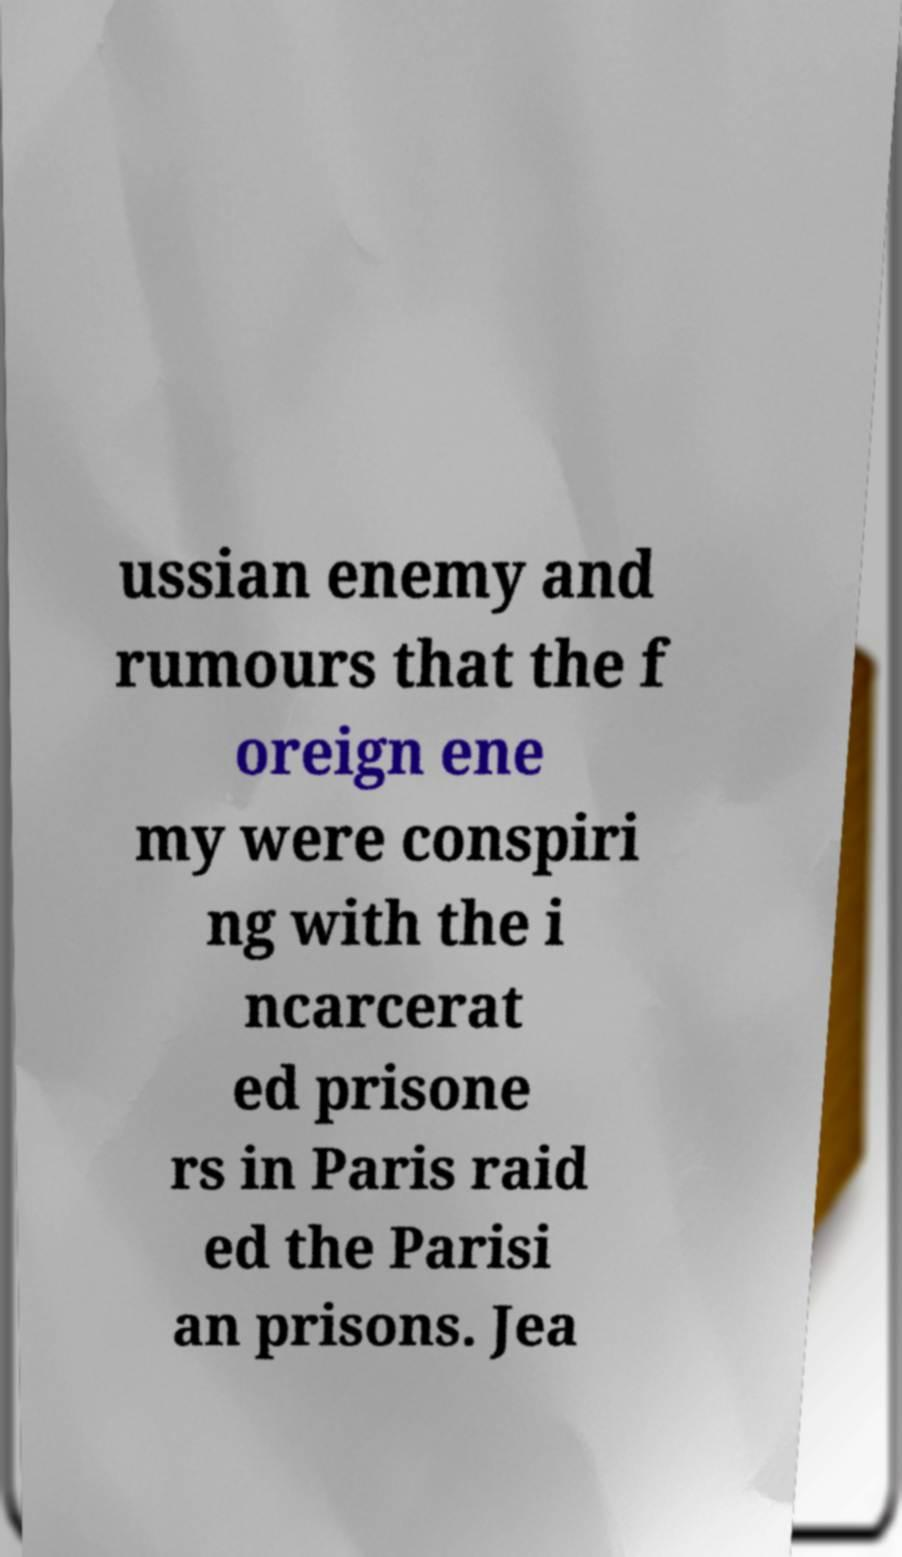What messages or text are displayed in this image? I need them in a readable, typed format. ussian enemy and rumours that the f oreign ene my were conspiri ng with the i ncarcerat ed prisone rs in Paris raid ed the Parisi an prisons. Jea 